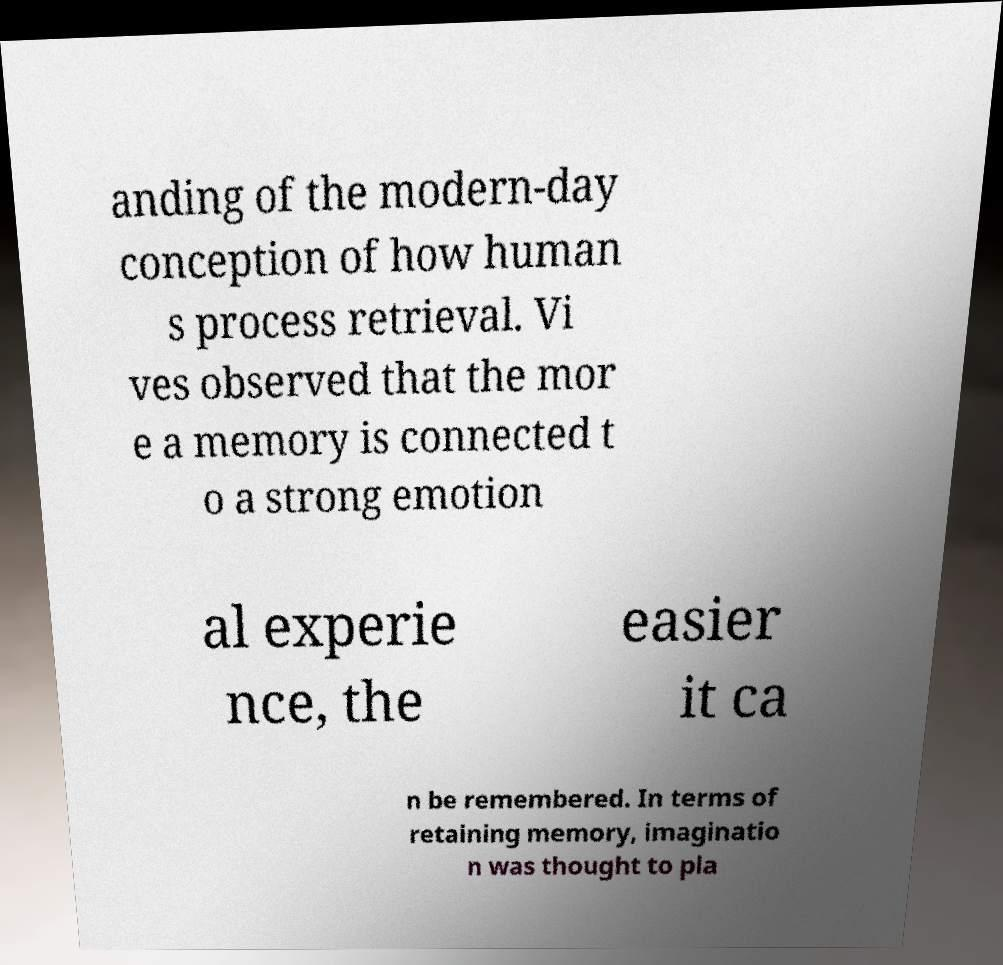Please read and relay the text visible in this image. What does it say? anding of the modern-day conception of how human s process retrieval. Vi ves observed that the mor e a memory is connected t o a strong emotion al experie nce, the easier it ca n be remembered. In terms of retaining memory, imaginatio n was thought to pla 